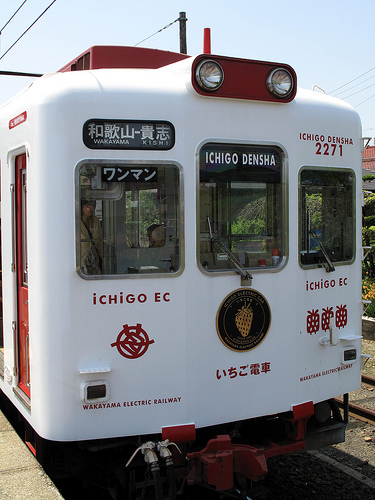<image>
Is the train next to the rails? Yes. The train is positioned adjacent to the rails, located nearby in the same general area. 